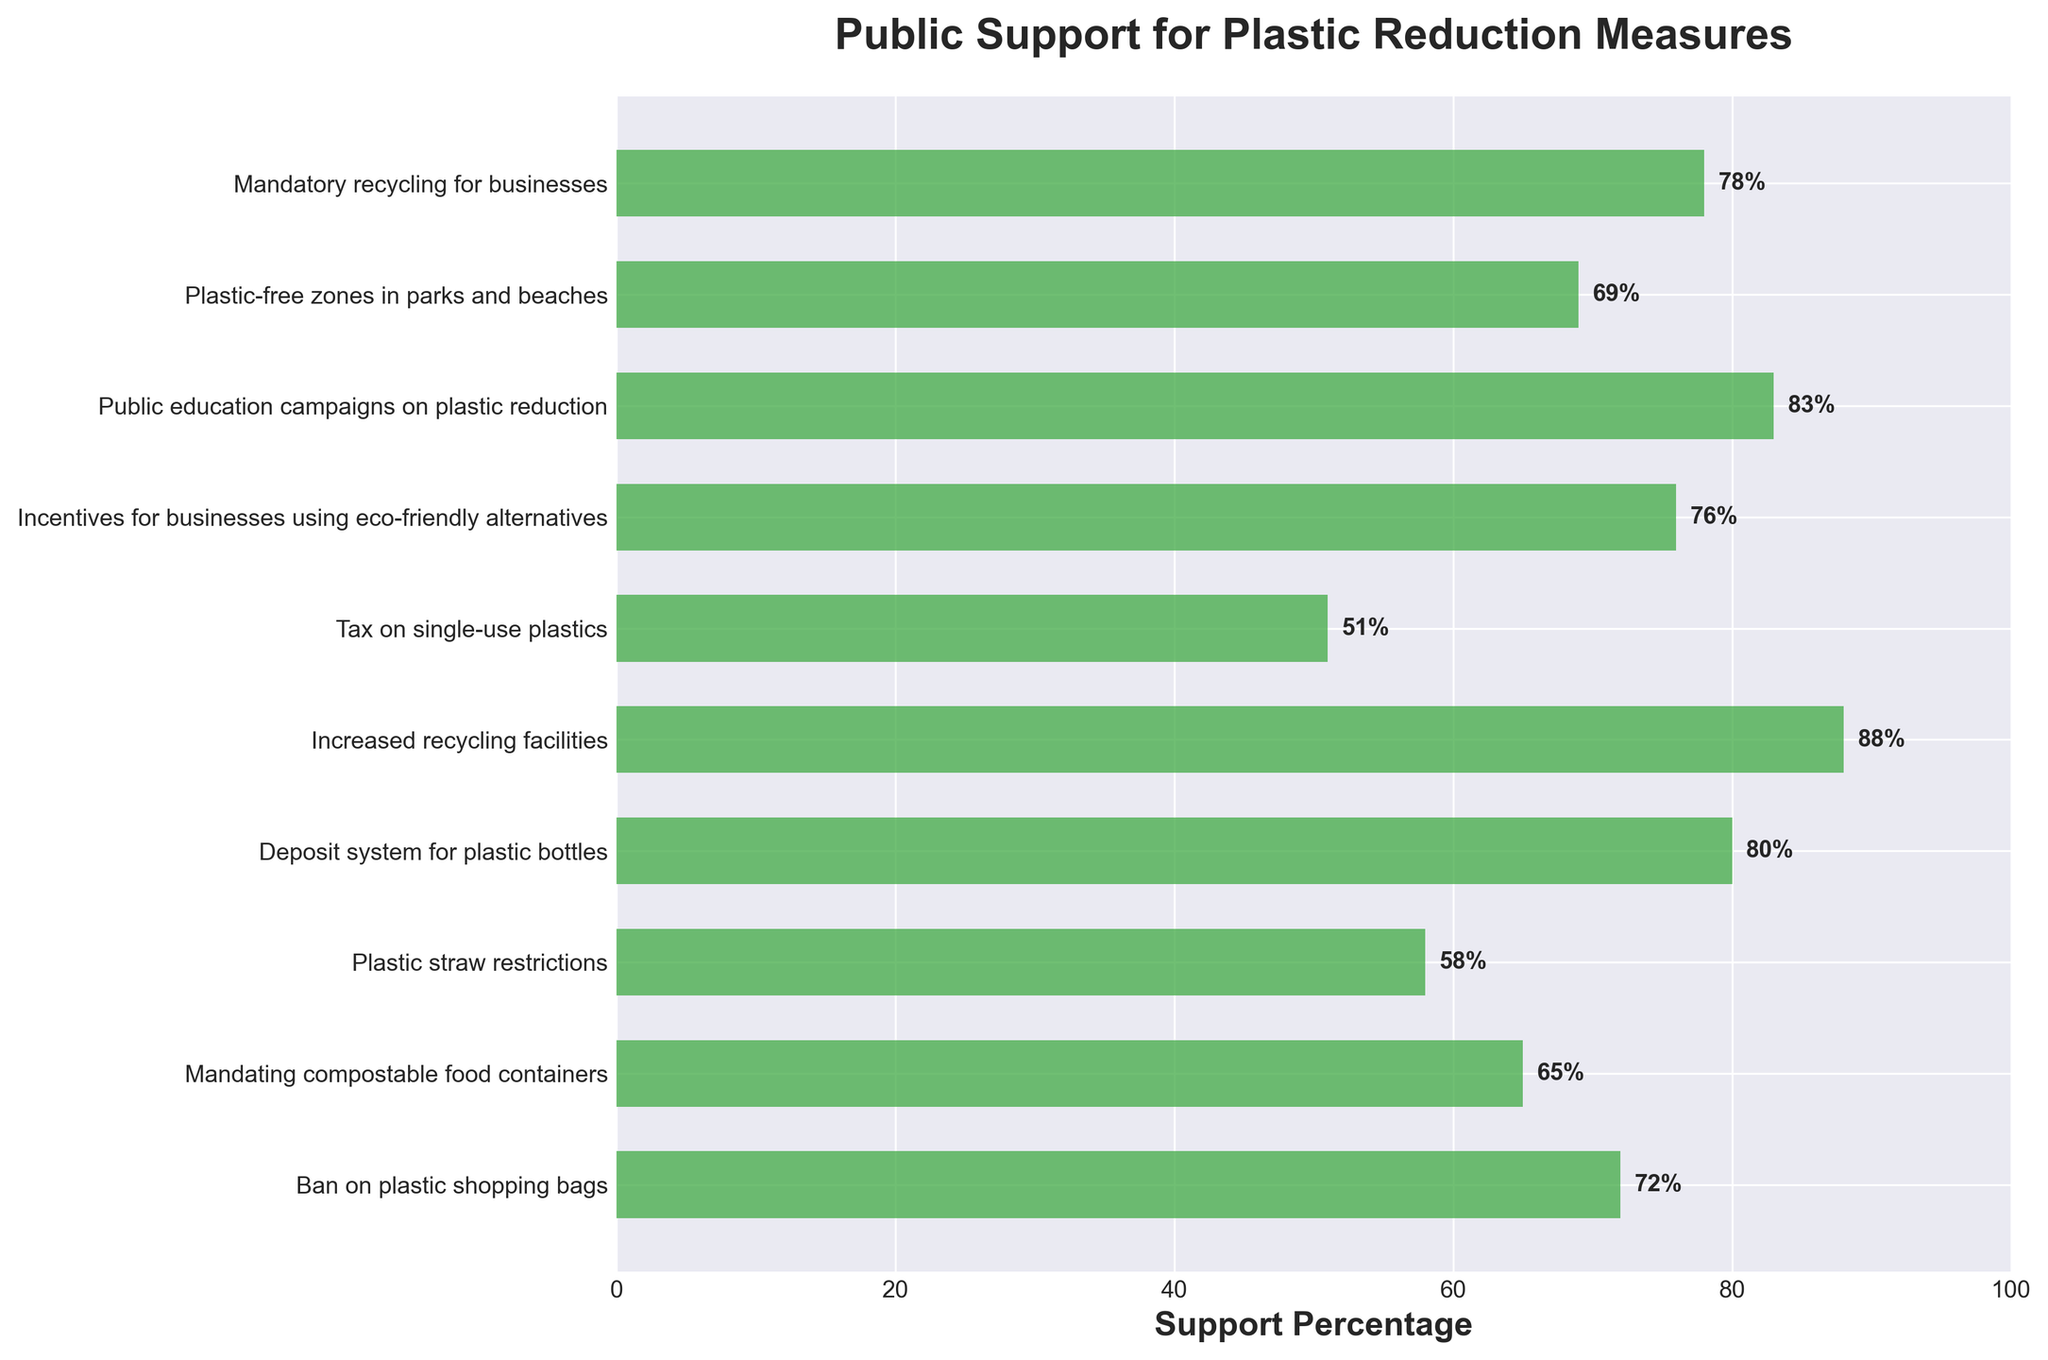Which plastic reduction measure has the highest support percentage? The highest bar in the chart represents the "Increased recycling facilities" measure with a support percentage of 88%.
Answer: Increased recycling facilities Which measure has the lowest support percentage? The lowest bar corresponds to the "Tax on single-use plastics" measure with a support percentage of 51%.
Answer: Tax on single-use plastics What is the difference in support percentage between the most supported and least supported measures? The measure with the highest support has 88%, and the measure with the lowest support has 51%. The difference is 88% - 51% = 37%.
Answer: 37% How many measures have a support percentage of 70% or higher? Measures with support percentages of 70% or higher are: Ban on plastic shopping bags (72%), Increased recycling facilities (88%), Incentives for businesses using eco-friendly alternatives (76%), Public education campaigns on plastic reduction (83%), and Mandatory recycling for businesses (78%). There are 5 measures in total.
Answer: 5 What is the average support percentage for the measures listed? Sum all the percentages: 72 + 65 + 58 + 80 + 88 + 51 + 76 + 83 + 69 + 78 = 720. There are 10 measures, so the average is 720 / 10 = 72%.
Answer: 72% Which measure has a support percentage closest to 75%? The support percentages near 75% are for measures with 72% and 76%. The "Incentives for businesses using eco-friendly alternatives" measure has a support percentage of 76%, which is closest to 75%.
Answer: Incentives for businesses using eco-friendly alternatives Is the support percentage for "Plastic straw restrictions" greater or less than 60%? The bar for "Plastic straw restrictions" shows a support percentage of 58%, which is less than 60%.
Answer: Less than 60% What is the total support percentage of the three most supported measures? The three most supported measures are Increased recycling facilities (88%), Public education campaigns on plastic reduction (83%), and Deposit system for plastic bottles (80%). The total support percentage is 88 + 83 + 80 = 251%.
Answer: 251% Which measures have a support rate that is greater than 70% but less than 85%? Measures satisfying this condition are: Ban on plastic shopping bags (72%), Deposit system for plastic bottles (80%), Incentives for businesses using eco-friendly alternatives (76%), and Mandatory recycling for businesses (78%).
Answer: Ban on plastic shopping bags, Deposit system for plastic bottles, Incentives for businesses using eco-friendly alternatives, Mandatory recycling for businesses Which visual element helps easily identify each bar's value on the chart? The values are directly labeled at the end of each bar, displaying the percentage for easy reference.
Answer: Labeled values 